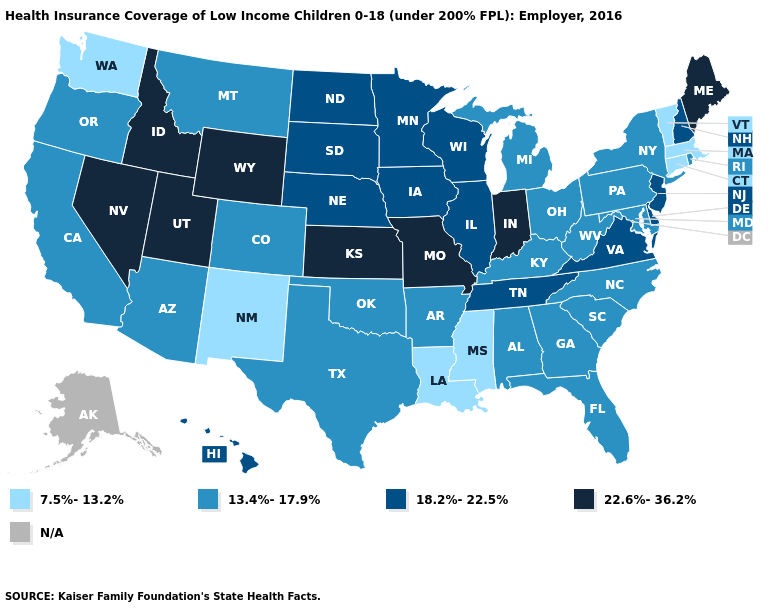What is the lowest value in states that border New Hampshire?
Answer briefly. 7.5%-13.2%. How many symbols are there in the legend?
Short answer required. 5. Among the states that border Connecticut , which have the lowest value?
Quick response, please. Massachusetts. Does Rhode Island have the highest value in the USA?
Short answer required. No. Among the states that border South Carolina , which have the highest value?
Keep it brief. Georgia, North Carolina. Does Pennsylvania have the highest value in the Northeast?
Give a very brief answer. No. What is the value of Nebraska?
Quick response, please. 18.2%-22.5%. What is the lowest value in the USA?
Be succinct. 7.5%-13.2%. What is the lowest value in states that border New Mexico?
Quick response, please. 13.4%-17.9%. What is the lowest value in states that border Pennsylvania?
Give a very brief answer. 13.4%-17.9%. What is the value of New Hampshire?
Answer briefly. 18.2%-22.5%. Does the map have missing data?
Be succinct. Yes. 